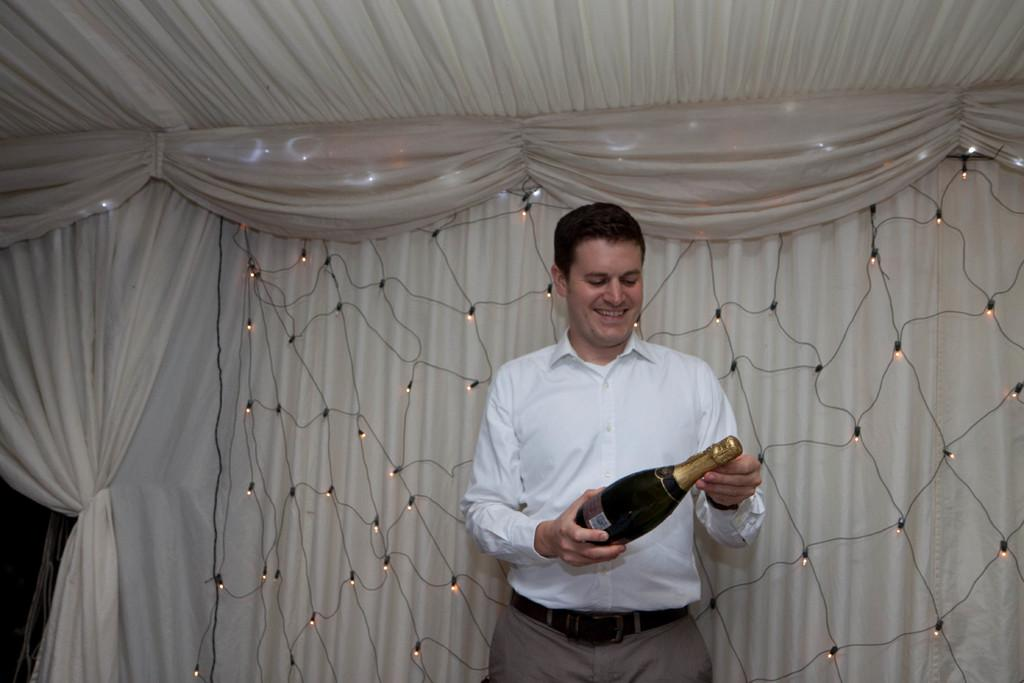Who is present in the image? There is a man in the image. What is the man doing in the image? The man is smiling in the image. What object is the man holding in the image? The man is holding a wine bottle in the image. What can be seen in the background of the image? There is a curtain and lights visible in the background of the image. What type of coal is the man using to fuel the fire in the image? There is no coal or fire present in the image; it features a man holding a wine bottle and smiling. How many sisters does the man have in the image? There is no mention of any sisters in the image; it only shows a man holding a wine bottle and smiling. 